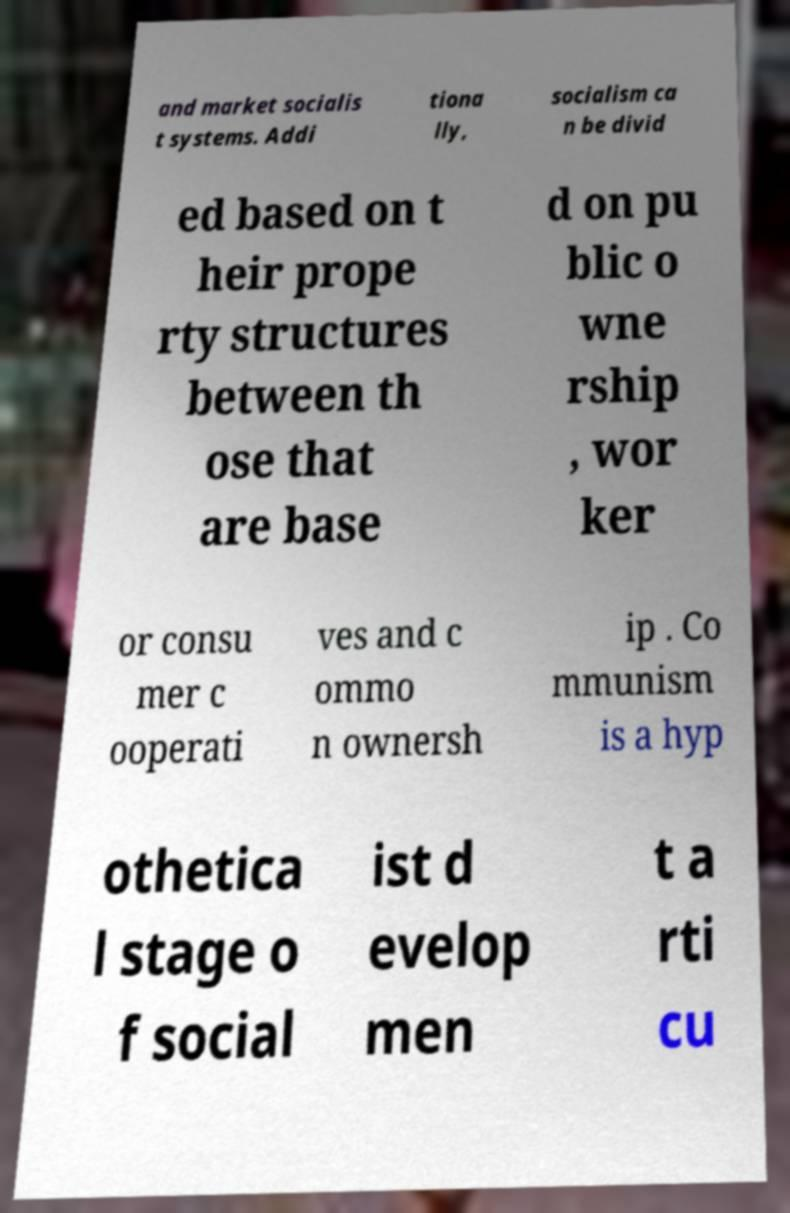Could you assist in decoding the text presented in this image and type it out clearly? and market socialis t systems. Addi tiona lly, socialism ca n be divid ed based on t heir prope rty structures between th ose that are base d on pu blic o wne rship , wor ker or consu mer c ooperati ves and c ommo n ownersh ip . Co mmunism is a hyp othetica l stage o f social ist d evelop men t a rti cu 